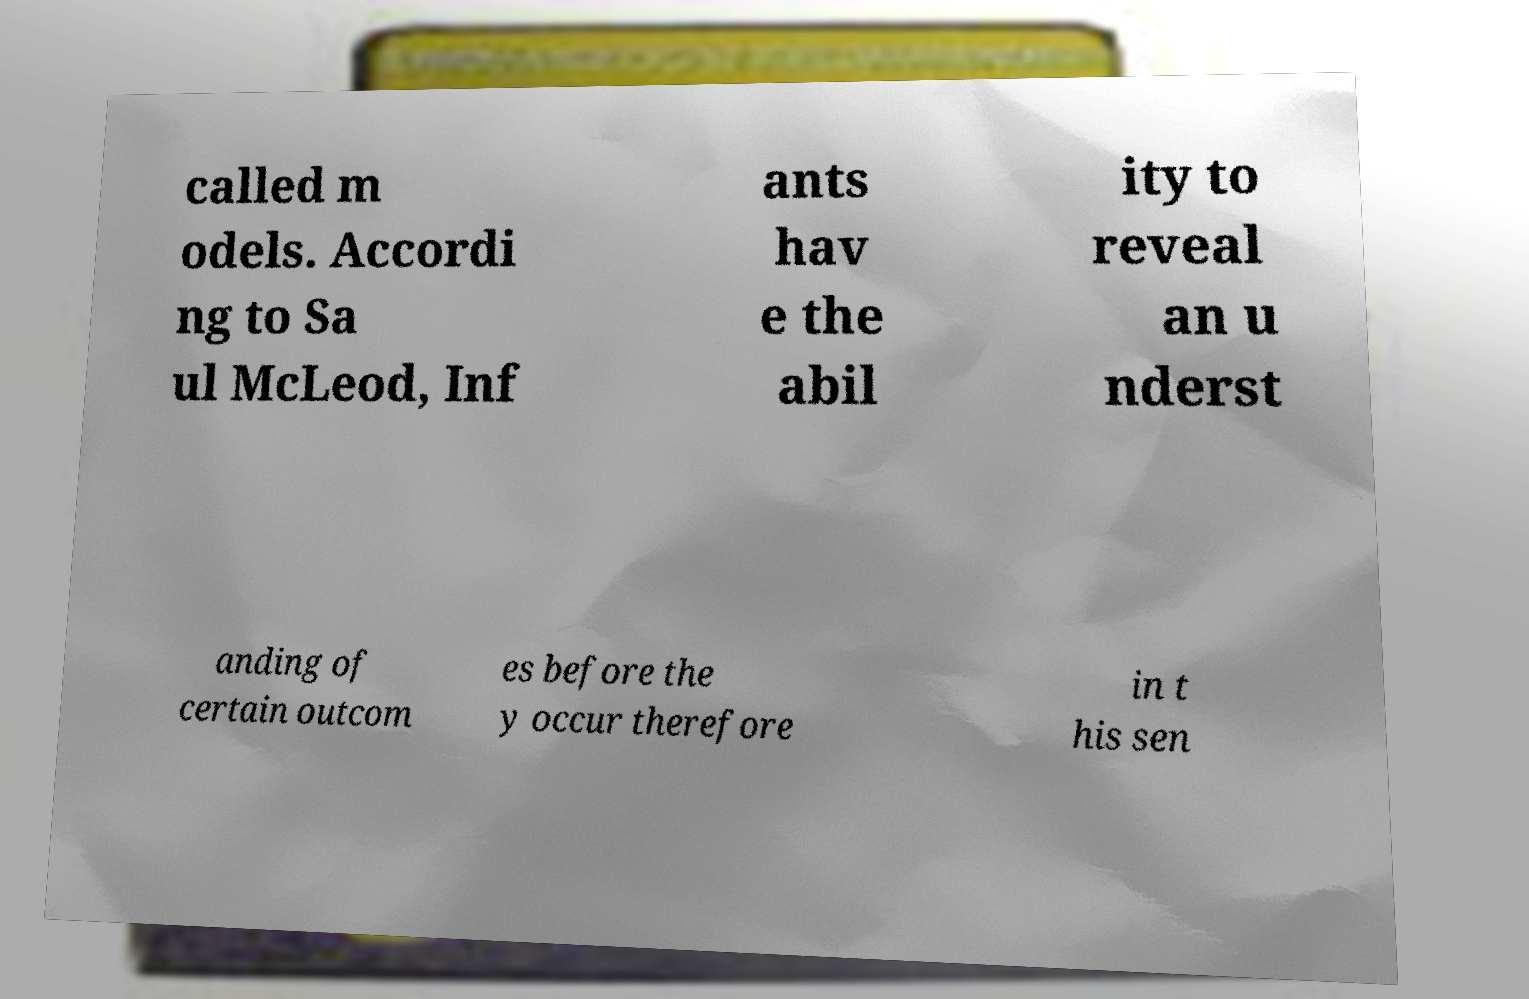Could you assist in decoding the text presented in this image and type it out clearly? called m odels. Accordi ng to Sa ul McLeod, Inf ants hav e the abil ity to reveal an u nderst anding of certain outcom es before the y occur therefore in t his sen 